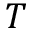Convert formula to latex. <formula><loc_0><loc_0><loc_500><loc_500>T</formula> 